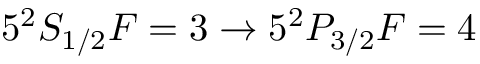<formula> <loc_0><loc_0><loc_500><loc_500>5 ^ { 2 } S _ { 1 / 2 } F = 3 \rightarrow 5 ^ { 2 } P _ { 3 / 2 } F = 4</formula> 